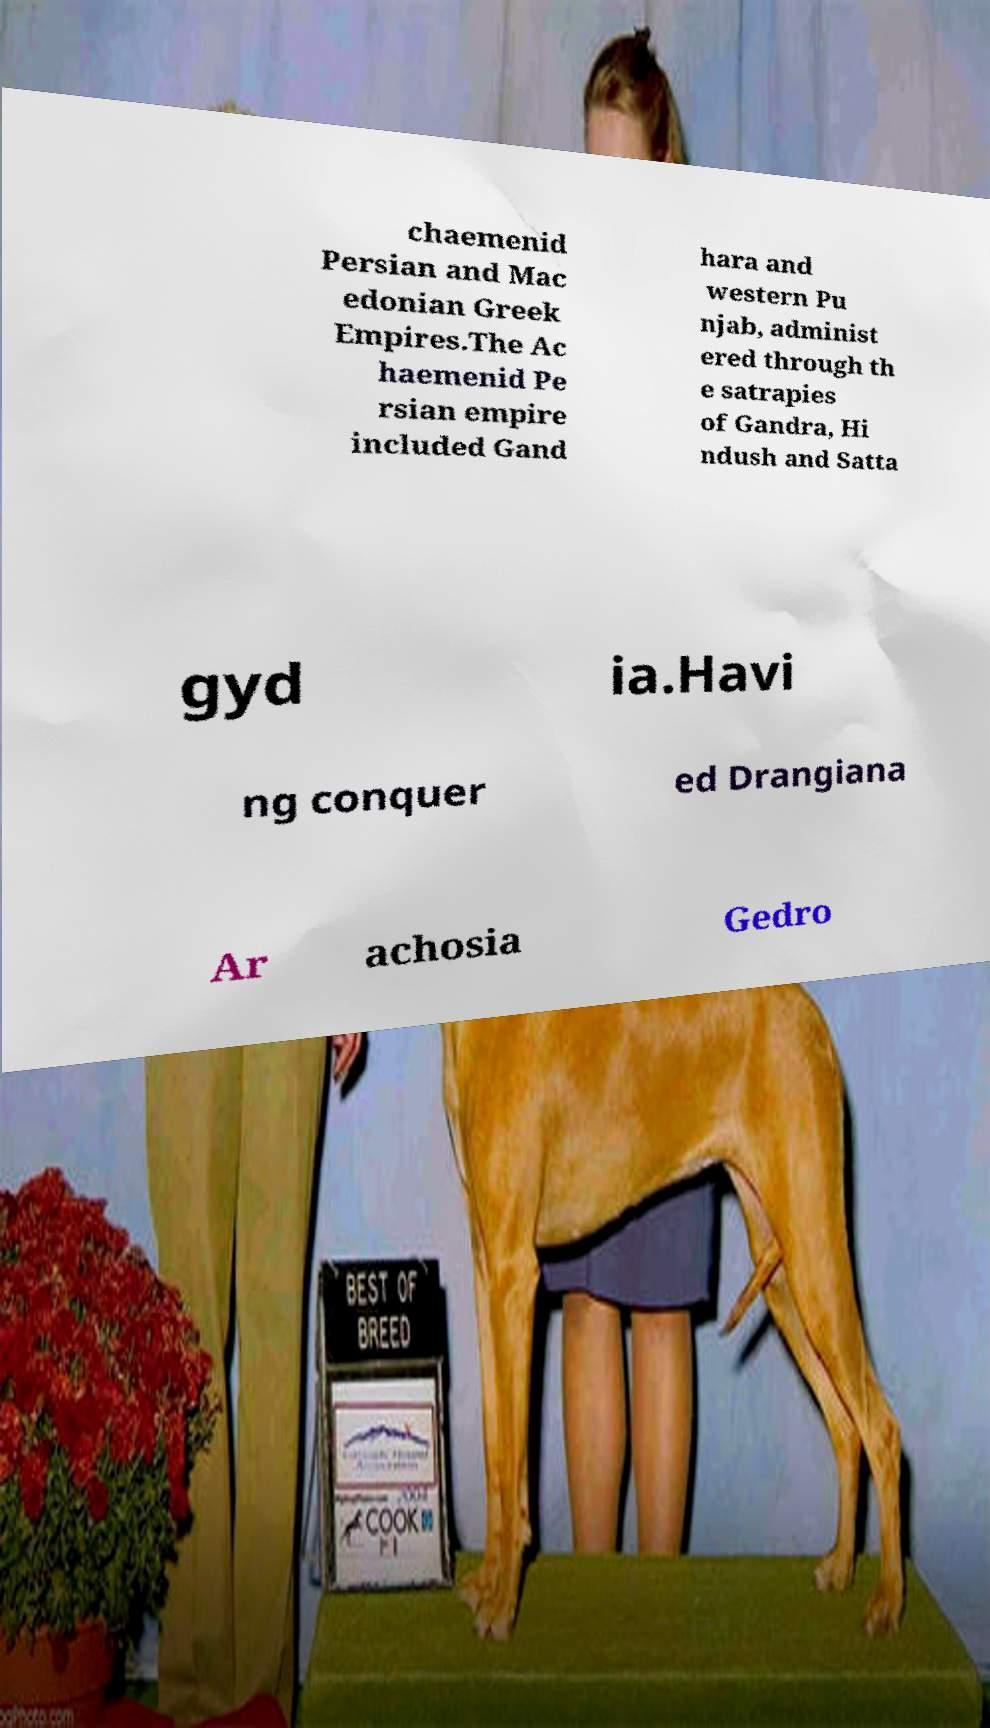There's text embedded in this image that I need extracted. Can you transcribe it verbatim? chaemenid Persian and Mac edonian Greek Empires.The Ac haemenid Pe rsian empire included Gand hara and western Pu njab, administ ered through th e satrapies of Gandra, Hi ndush and Satta gyd ia.Havi ng conquer ed Drangiana Ar achosia Gedro 